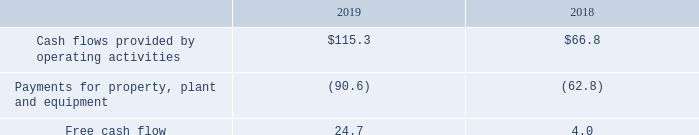Free Cash Flow. We define free cash flow ("FCF"), a non-GAAP financial measure, as cash flow provided by operations less capital expenditures. FCF was$ 24.7 million for fiscal 2019 compared to $4.0 million for fiscal 2018, an increase of $20.7 million.
Non-GAAP financial measures, including FCF, are used for internal management assessments because such measures provide additional insight to investors into ongoing financial performance. In particular, we provide FCF because we believe it offers insight into the metrics that are driving management decisions. We view FCF as an important financial metric as it demonstrates our ability to generate cash and can allow us to pursue opportunities that enhance shareholder value. FCF is a non-GAAP financial measure that should be considered in addition to, not as a substitute for, measures of our financial performance prepared in accordance with GAAP.
A reconciliation of FCF to our financial statements that were prepared using GAAP follows (in millions):
How was Free Cash Flow defined by the company? As cash flow provided by operations less capital expenditures. What was the free cash flow in 2018?
Answer scale should be: million. 4.0. Which years does the table provide information for the company's free cash flows? 2019, 2018. How many years did cash flows provided by operating activities exceed $100 million? 2019
Answer: 1. What was the change in Payments for property, plant and equipment between 2018 and 2019?
Answer scale should be: million. -90.6-(-62.8)
Answer: -27.8. What was the percentage change in the free cash flow between 2018 and 2019?
Answer scale should be: percent. (24.7-4.0)/4.0
Answer: 517.5. 